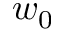Convert formula to latex. <formula><loc_0><loc_0><loc_500><loc_500>w _ { 0 }</formula> 